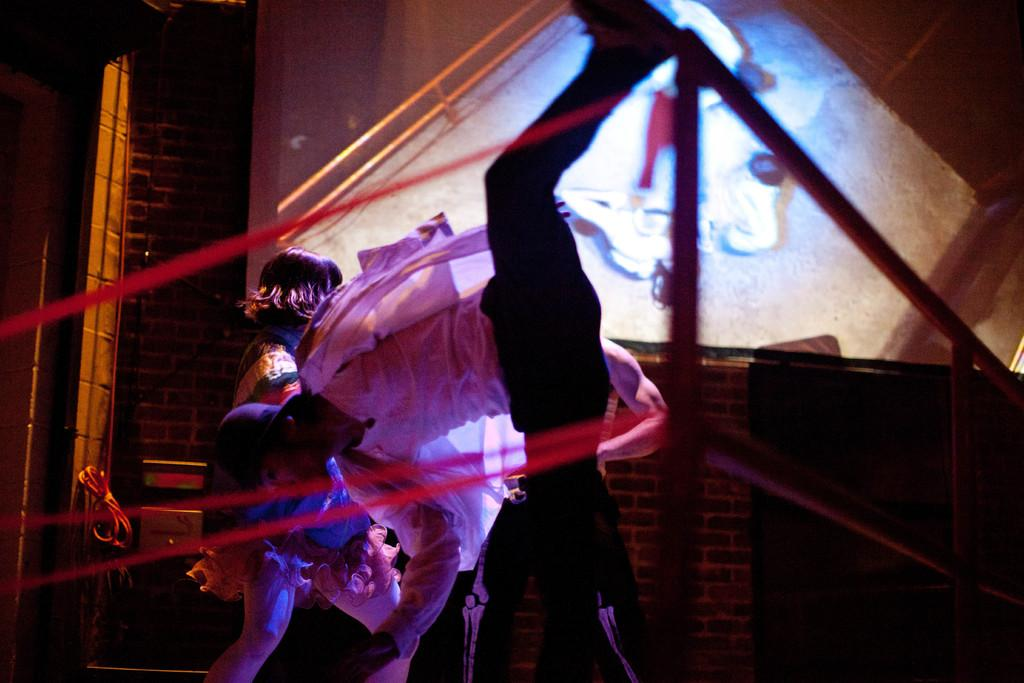What type of animal is in the image? There is a cat in the image. What is the cat doing in the image? The cat is sitting on a chair. Can you describe the chair in the image? The chair is red in color. What type of yoke is the bear carrying in the image? There is no bear or yoke present in the image; it features a cat sitting on a red chair. 